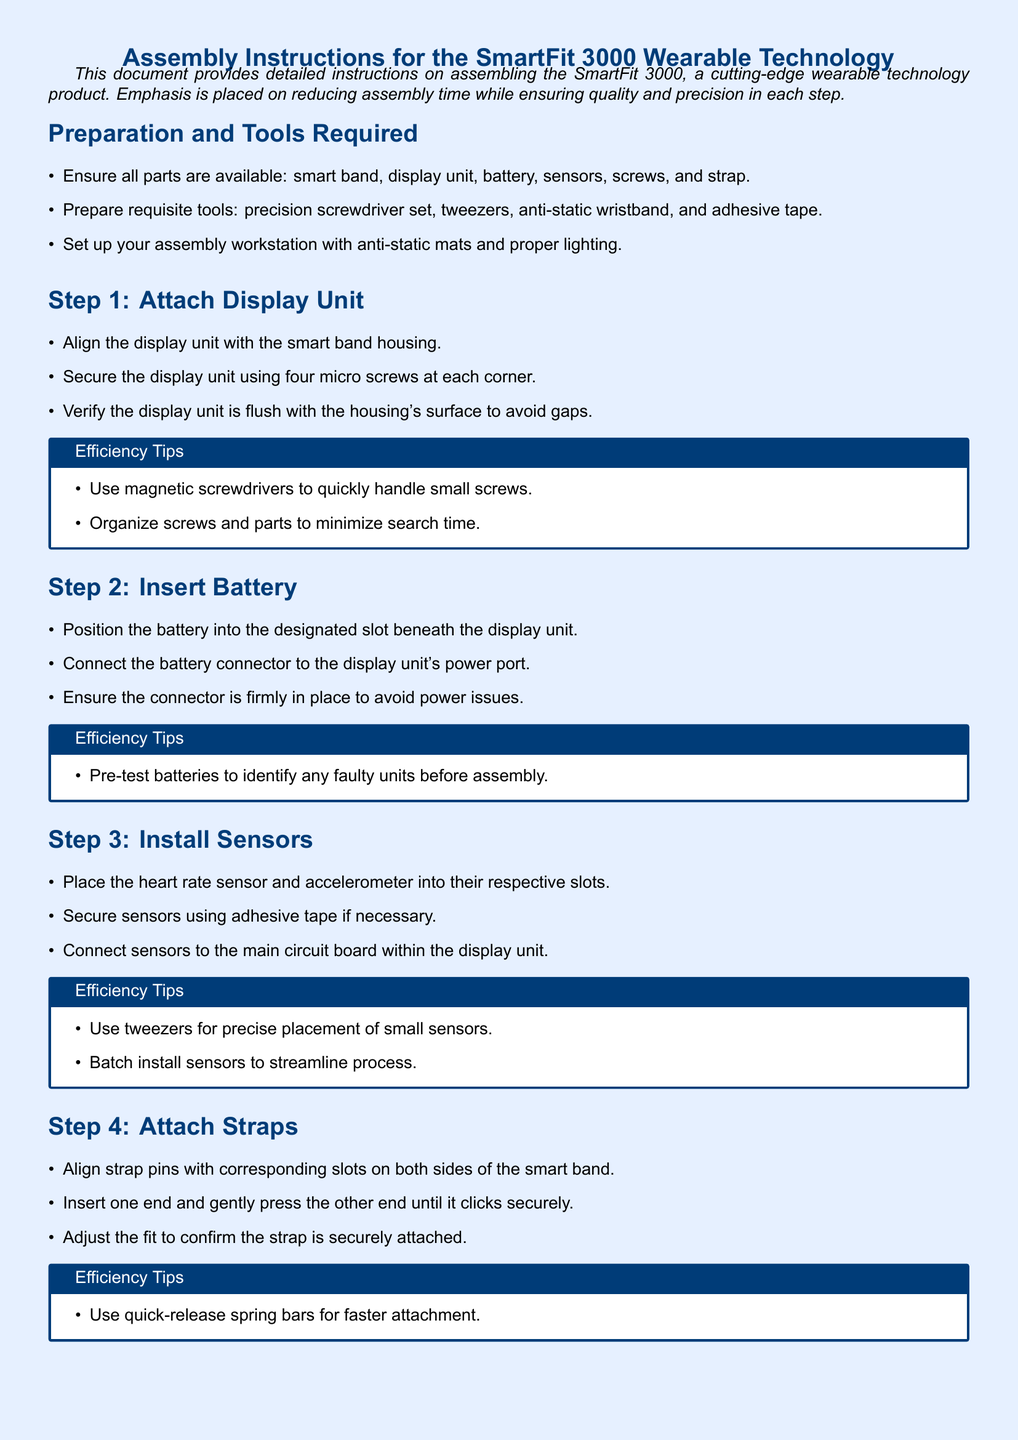What is the name of the wearable technology product? The document specifies the product's name as "SmartFit 3000."
Answer: SmartFit 3000 How many micro screws are required to secure the display unit? The instructions state that four micro screws are needed at each corner of the display unit.
Answer: Four What should be used to pre-test batteries? The document suggests conducting a pre-test to identify faulty units before assembly.
Answer: Pre-test What tool is recommended for precise placement of small sensors? The efficiency tip recommends using tweezers for placing sensors accurately.
Answer: Tweezers What is the last step in the assembly process? The final check involves performing a visual inspection and powering on the device to verify functionality.
Answer: Final Check and Testing Which tool is suggested for faster strap attachment? The efficiency tip mentions using quick-release spring bars for a quicker process.
Answer: Quick-release spring bars What kind of mat should be set on the assembly workstation? The preparation section states to use anti-static mats in the workstation setup.
Answer: Anti-static mats What type of tools should be prepared for assembly? The document lists a precision screwdriver set, tweezers, anti-static wristband, and adhesive tape as required tools.
Answer: Precision screwdriver set, tweezers, anti-static wristband, adhesive tape 